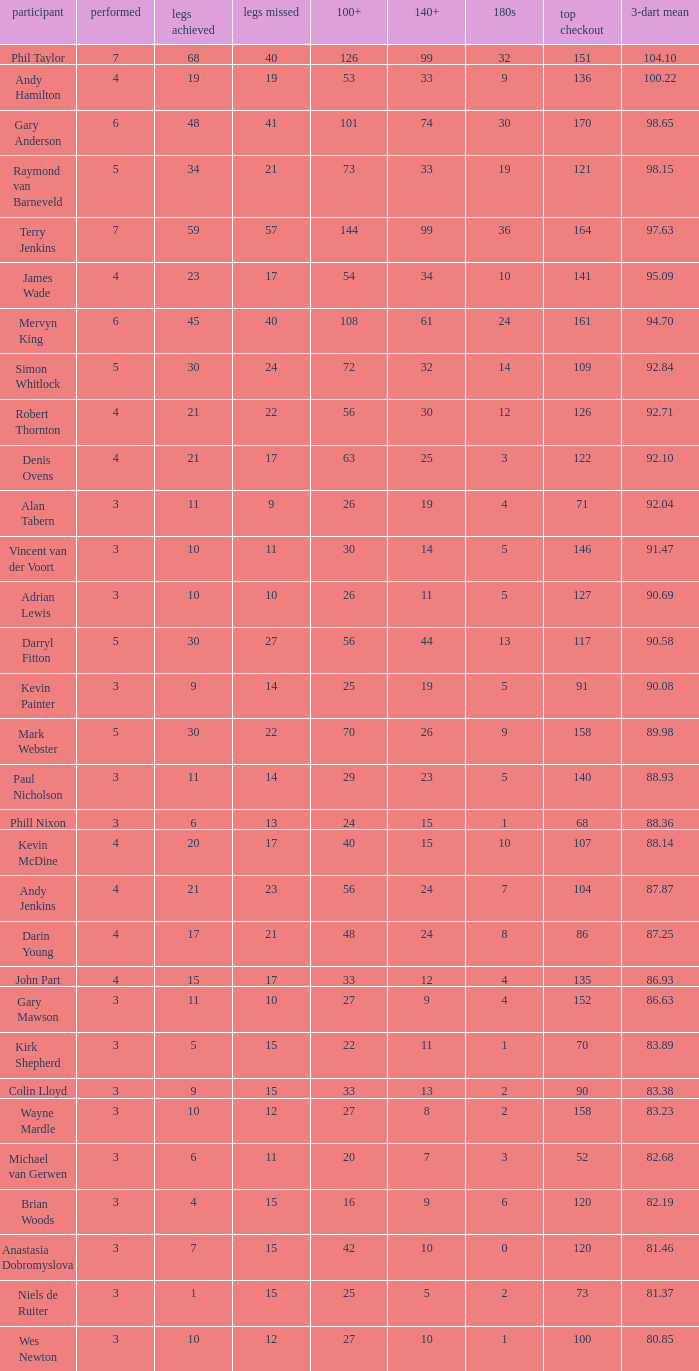Who is the player with 41 legs lost? Gary Anderson. 